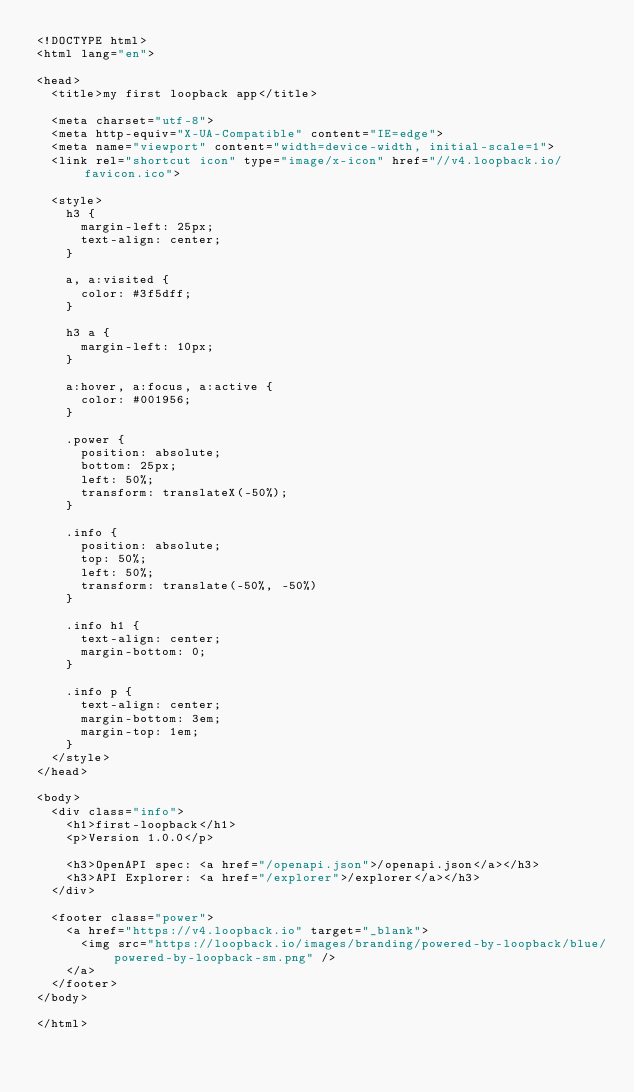Convert code to text. <code><loc_0><loc_0><loc_500><loc_500><_HTML_><!DOCTYPE html>
<html lang="en">

<head>
  <title>my first loopback app</title>

  <meta charset="utf-8">
  <meta http-equiv="X-UA-Compatible" content="IE=edge">
  <meta name="viewport" content="width=device-width, initial-scale=1">
  <link rel="shortcut icon" type="image/x-icon" href="//v4.loopback.io/favicon.ico">

  <style>
    h3 {
      margin-left: 25px;
      text-align: center;
    }

    a, a:visited {
      color: #3f5dff;
    }

    h3 a {
      margin-left: 10px;
    }

    a:hover, a:focus, a:active {
      color: #001956;
    }

    .power {
      position: absolute;
      bottom: 25px;
      left: 50%;
      transform: translateX(-50%);
    }

    .info {
      position: absolute;
      top: 50%;
      left: 50%;
      transform: translate(-50%, -50%)
    }

    .info h1 {
      text-align: center;
      margin-bottom: 0;
    }

    .info p {
      text-align: center;
      margin-bottom: 3em;
      margin-top: 1em;
    }
  </style>
</head>

<body>
  <div class="info">
    <h1>first-loopback</h1>
    <p>Version 1.0.0</p>

    <h3>OpenAPI spec: <a href="/openapi.json">/openapi.json</a></h3>
    <h3>API Explorer: <a href="/explorer">/explorer</a></h3>
  </div>

  <footer class="power">
    <a href="https://v4.loopback.io" target="_blank">
      <img src="https://loopback.io/images/branding/powered-by-loopback/blue/powered-by-loopback-sm.png" />
    </a>
  </footer>
</body>

</html>
</code> 